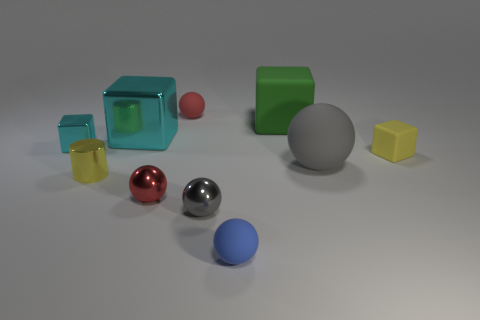Subtract all tiny metallic spheres. How many spheres are left? 3 Subtract all cyan blocks. How many red spheres are left? 2 Subtract all gray spheres. How many spheres are left? 3 Subtract all cubes. How many objects are left? 6 Subtract all tiny metal blocks. Subtract all gray spheres. How many objects are left? 7 Add 3 small red balls. How many small red balls are left? 5 Add 2 big green metal cylinders. How many big green metal cylinders exist? 2 Subtract 1 cyan blocks. How many objects are left? 9 Subtract all cyan spheres. Subtract all gray blocks. How many spheres are left? 5 